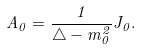Convert formula to latex. <formula><loc_0><loc_0><loc_500><loc_500>A _ { 0 } = \frac { 1 } { \triangle - m _ { 0 } ^ { 2 } } J _ { 0 } .</formula> 